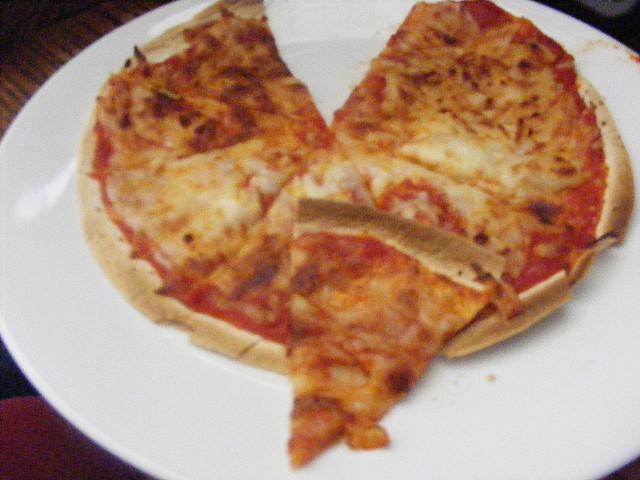How many slices are moved from the pizza?
Give a very brief answer. 1. How many pizzas are in the picture?
Give a very brief answer. 2. How many people are on the motorcycle?
Give a very brief answer. 0. 